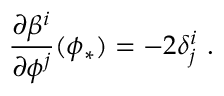<formula> <loc_0><loc_0><loc_500><loc_500>{ \frac { \partial \beta ^ { i } } { \partial \phi ^ { j } } } ( \phi _ { * } ) = - 2 \delta _ { j } ^ { i } \ .</formula> 